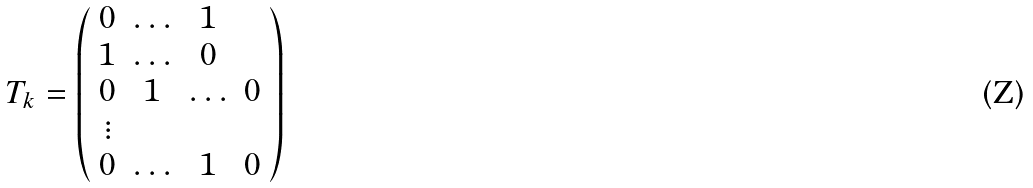<formula> <loc_0><loc_0><loc_500><loc_500>T _ { k } = \left ( \begin{array} { c c c c } { 0 } & { \dots } & { 1 } \\ { 1 } & { \dots } & { 0 } \\ { 0 } & { 1 } & { \dots } & { 0 } \\ { \vdots } \\ { 0 } & { \dots } & { 1 } & { 0 } \end{array} \right )</formula> 